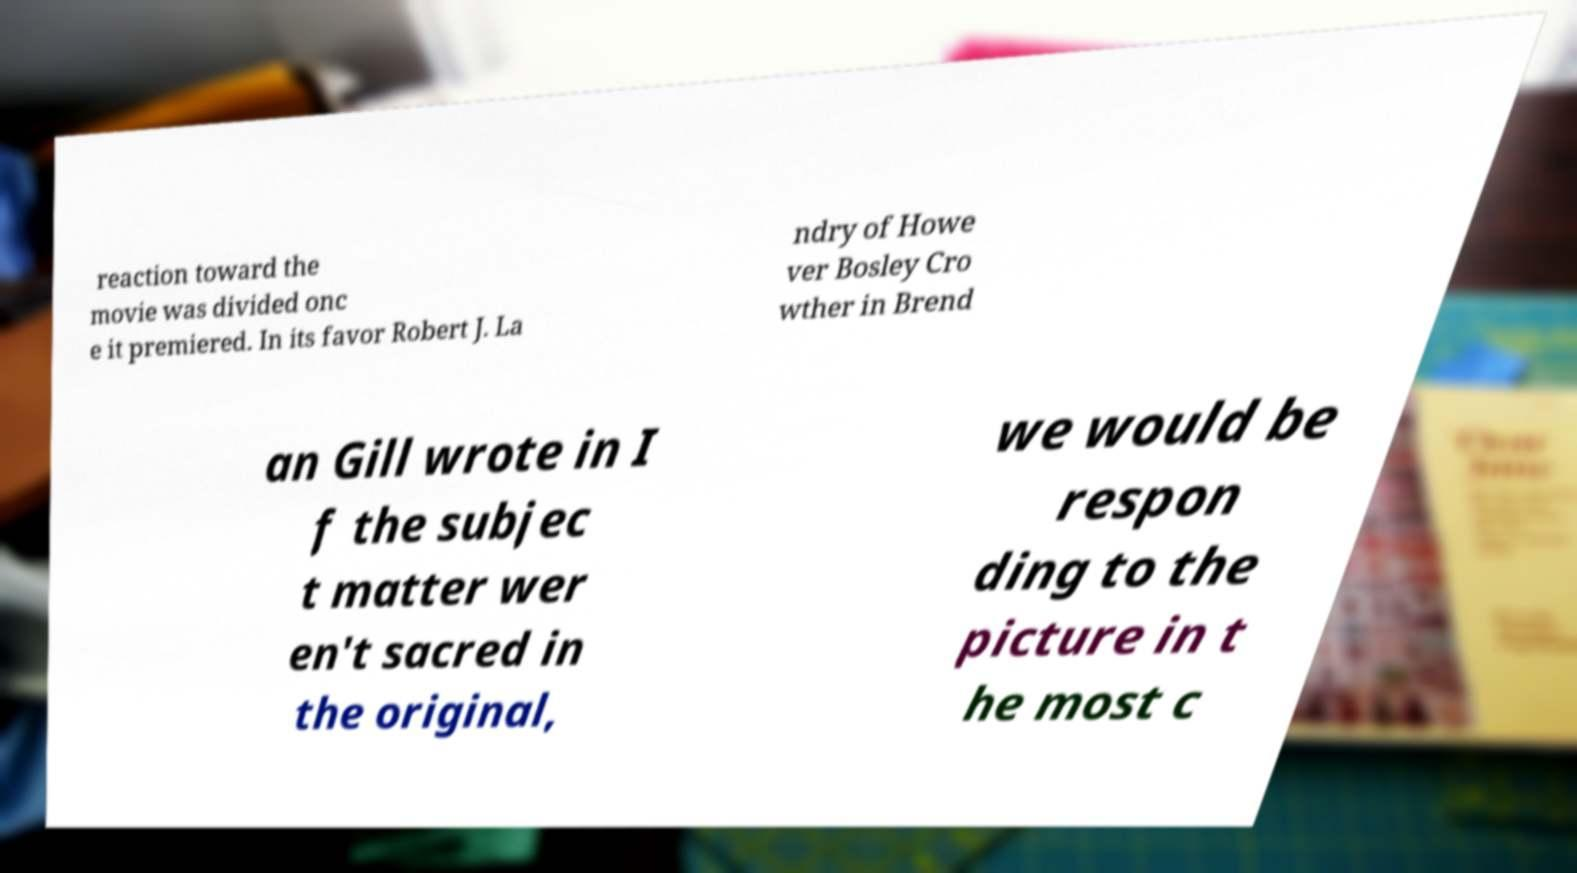Can you read and provide the text displayed in the image?This photo seems to have some interesting text. Can you extract and type it out for me? reaction toward the movie was divided onc e it premiered. In its favor Robert J. La ndry of Howe ver Bosley Cro wther in Brend an Gill wrote in I f the subjec t matter wer en't sacred in the original, we would be respon ding to the picture in t he most c 